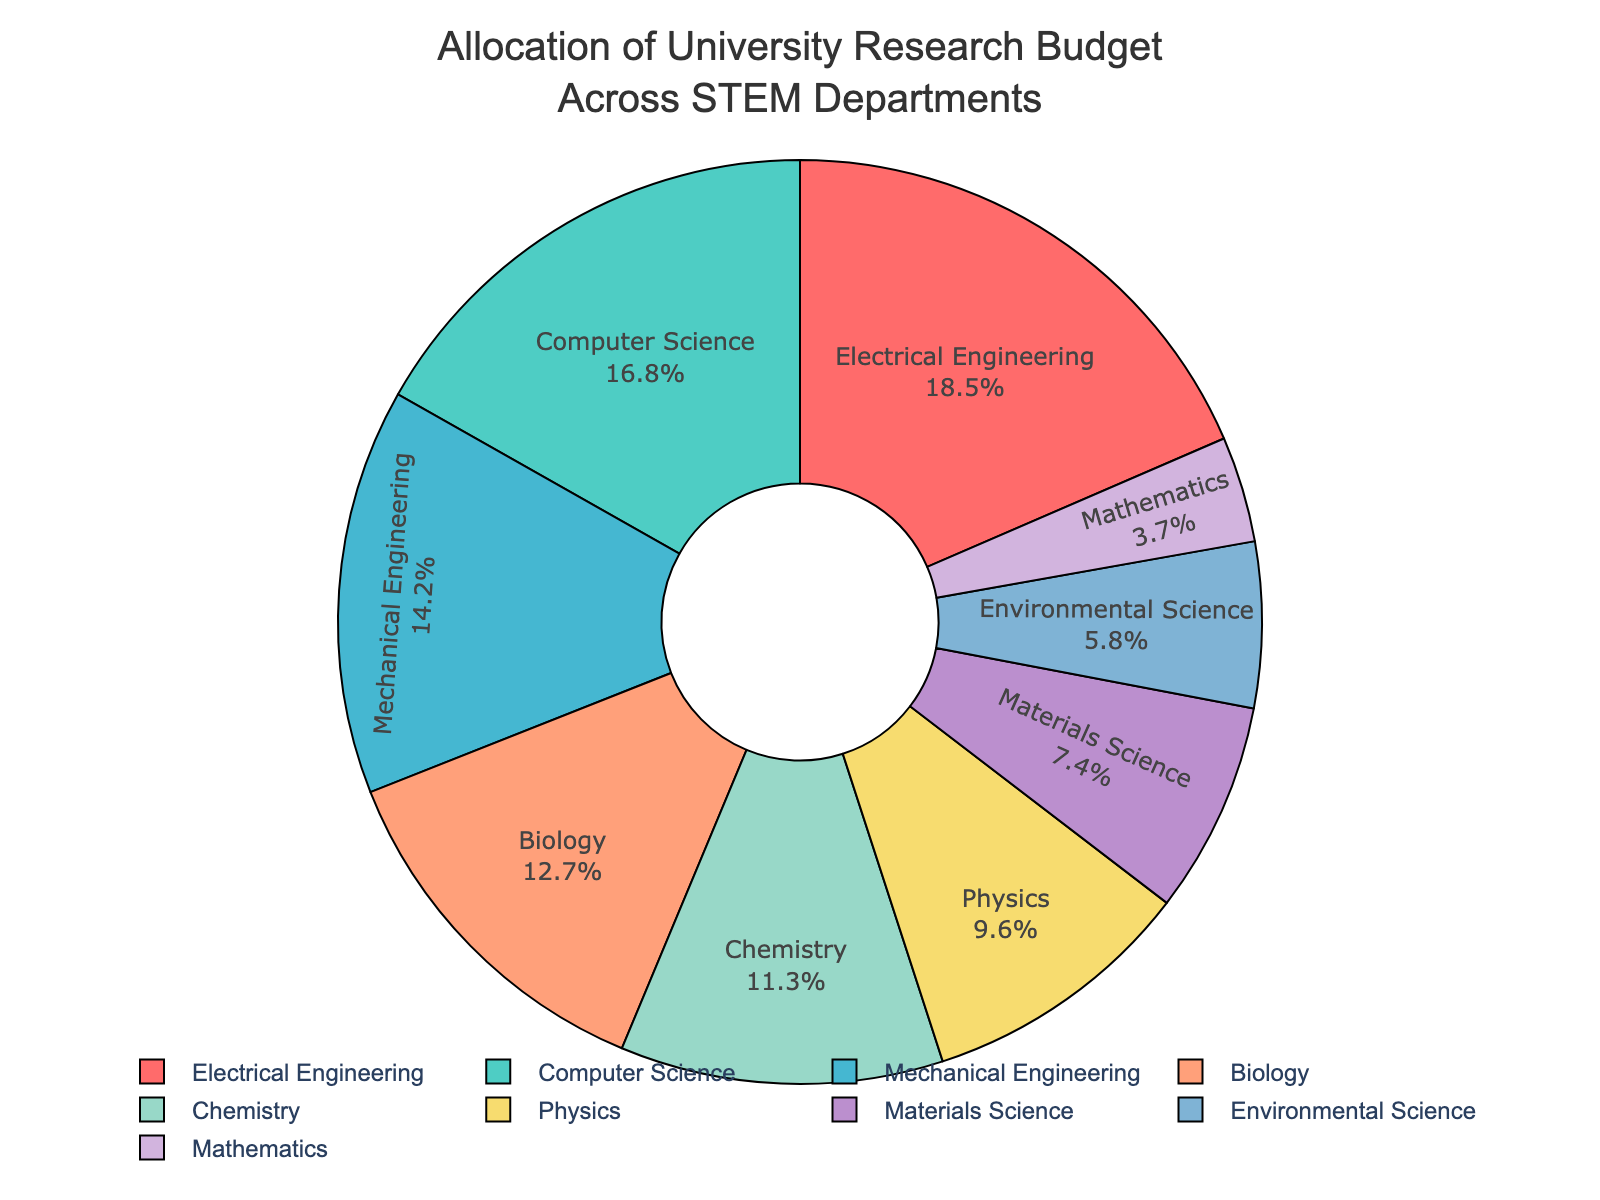What percentage of the budget is allocated to Electrical Engineering and Computer Science combined? Electrical Engineering has 18.5% and Computer Science has 16.8%. Adding them together: 18.5% + 16.8% = 35.3%
Answer: 35.3% Which department receives the smallest portion of the budget? By looking at the pie chart, the smallest segment is assigned to Mathematics with 3.7%.
Answer: Mathematics What is the difference in budget allocation between Biology and Chemistry? Biology has 12.7% and Chemistry has 11.3%, so the difference is 12.7% - 11.3% = 1.4%
Answer: 1.4% Which departments have a budget allocation greater than 15%? Departments with more than 15% of the budget are Electrical Engineering (18.5%) and Computer Science (16.8%).
Answer: Electrical Engineering, Computer Science What is the total budget allocation for Mechanical Engineering, Biology, and Chemistry combined? Mechanical Engineering has 14.2%, Biology has 12.7%, and Chemistry has 11.3%. Adding them together: 14.2% + 12.7% + 11.3% = 38.2%
Answer: 38.2% Which department, among Physics and Materials Science, has a higher budget allocation and by how much? Physics has 9.6% and Materials Science has 7.4%. Physics has a higher budget allocation by 9.6% - 7.4% = 2.2%
Answer: Physics, 2.2% What fraction of the budget is allocated to Environmental Science and Mathematics combined? Environmental Science has 5.8% and Mathematics has 3.7%. Adding them together: 5.8% + 3.7% = 9.5%. As a fraction, 9.5% can be written as 9.5/100 or simplified to 19/200.
Answer: \( \frac{19}{200} \) How does the budget allocation for Computer Science compare visually to Environmental Science? Visually, the slice for Computer Science is significantly larger than that of Environmental Science, indicating a higher budget allocation for Computer Science (16.8%) compared to Environmental Science (5.8%).
Answer: Computer Science has a larger allocation Which two departments have the closest budget allocation and what is the difference between them? By looking at the pie chart, Biology (12.7%) and Chemistry (11.3%) have the closest allocations. The difference is 12.7% - 11.3% = 1.4%
Answer: Biology and Chemistry, 1.4% 